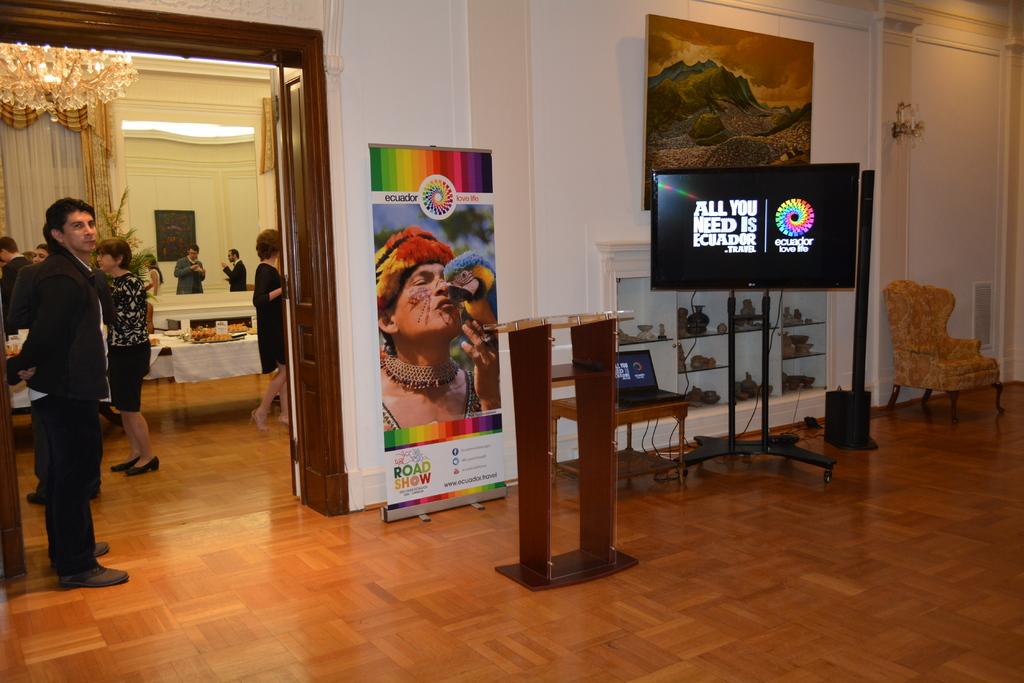According to the sign, all you need is what?
Offer a terse response. Ecuador. 